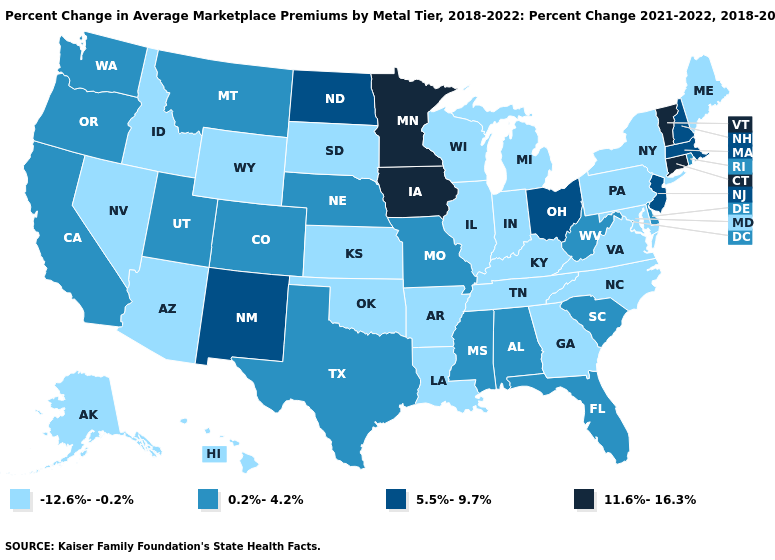Which states have the lowest value in the MidWest?
Answer briefly. Illinois, Indiana, Kansas, Michigan, South Dakota, Wisconsin. Which states have the highest value in the USA?
Give a very brief answer. Connecticut, Iowa, Minnesota, Vermont. Among the states that border Washington , does Oregon have the highest value?
Write a very short answer. Yes. What is the highest value in states that border Louisiana?
Concise answer only. 0.2%-4.2%. Among the states that border New Hampshire , does Vermont have the highest value?
Keep it brief. Yes. Does New Mexico have the highest value in the West?
Give a very brief answer. Yes. Does Indiana have the highest value in the MidWest?
Quick response, please. No. Among the states that border Idaho , which have the highest value?
Quick response, please. Montana, Oregon, Utah, Washington. What is the highest value in states that border Mississippi?
Concise answer only. 0.2%-4.2%. Name the states that have a value in the range 11.6%-16.3%?
Answer briefly. Connecticut, Iowa, Minnesota, Vermont. What is the value of Indiana?
Concise answer only. -12.6%--0.2%. Name the states that have a value in the range 5.5%-9.7%?
Short answer required. Massachusetts, New Hampshire, New Jersey, New Mexico, North Dakota, Ohio. Does New Mexico have the lowest value in the USA?
Concise answer only. No. Which states have the lowest value in the Northeast?
Quick response, please. Maine, New York, Pennsylvania. What is the value of South Carolina?
Short answer required. 0.2%-4.2%. 